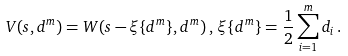Convert formula to latex. <formula><loc_0><loc_0><loc_500><loc_500>V ( s , { d } ^ { m } ) = W ( s - \xi \{ { d } ^ { m } \} , { d } ^ { m } ) \, , \, \xi \{ { d } ^ { m } \} = \frac { 1 } { 2 } \sum _ { i = 1 } ^ { m } d _ { i } \, .</formula> 